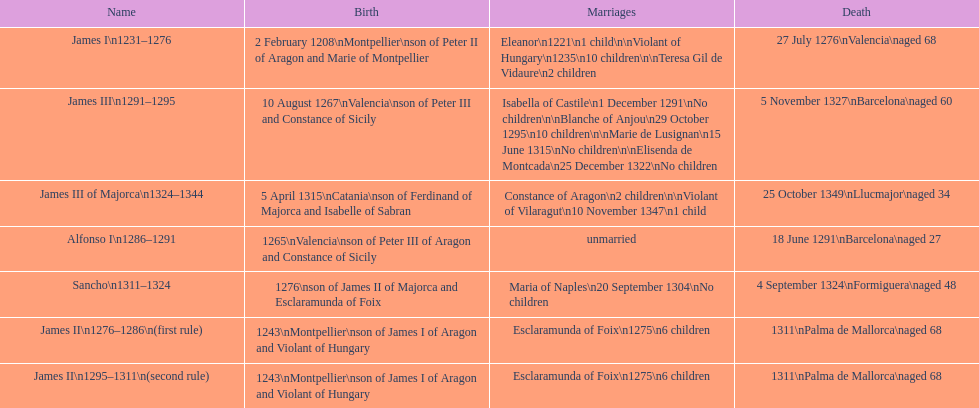Who came to power after the rule of james iii? James II. 